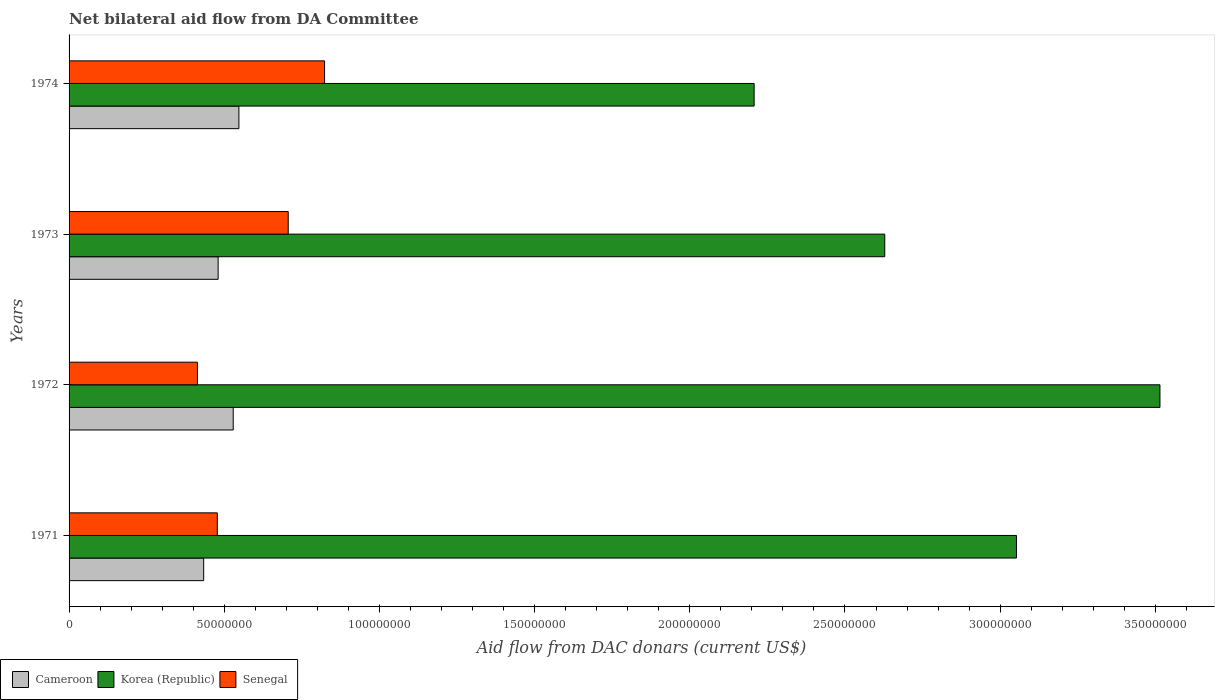How many groups of bars are there?
Offer a terse response. 4. How many bars are there on the 3rd tick from the top?
Your response must be concise. 3. What is the label of the 1st group of bars from the top?
Give a very brief answer. 1974. In how many cases, is the number of bars for a given year not equal to the number of legend labels?
Provide a succinct answer. 0. What is the aid flow in in Senegal in 1971?
Your answer should be very brief. 4.78e+07. Across all years, what is the maximum aid flow in in Senegal?
Offer a terse response. 8.23e+07. Across all years, what is the minimum aid flow in in Korea (Republic)?
Your answer should be very brief. 2.21e+08. What is the total aid flow in in Cameroon in the graph?
Provide a short and direct response. 1.99e+08. What is the difference between the aid flow in in Cameroon in 1972 and that in 1973?
Provide a short and direct response. 4.86e+06. What is the difference between the aid flow in in Korea (Republic) in 1973 and the aid flow in in Senegal in 1974?
Make the answer very short. 1.80e+08. What is the average aid flow in in Cameroon per year?
Ensure brevity in your answer.  4.98e+07. In the year 1971, what is the difference between the aid flow in in Cameroon and aid flow in in Korea (Republic)?
Provide a short and direct response. -2.62e+08. In how many years, is the aid flow in in Cameroon greater than 250000000 US$?
Your answer should be very brief. 0. What is the ratio of the aid flow in in Senegal in 1972 to that in 1974?
Give a very brief answer. 0.5. What is the difference between the highest and the second highest aid flow in in Senegal?
Offer a terse response. 1.17e+07. What is the difference between the highest and the lowest aid flow in in Korea (Republic)?
Make the answer very short. 1.31e+08. Is the sum of the aid flow in in Senegal in 1971 and 1973 greater than the maximum aid flow in in Korea (Republic) across all years?
Provide a succinct answer. No. What does the 3rd bar from the top in 1973 represents?
Your response must be concise. Cameroon. What does the 3rd bar from the bottom in 1971 represents?
Ensure brevity in your answer.  Senegal. Is it the case that in every year, the sum of the aid flow in in Senegal and aid flow in in Korea (Republic) is greater than the aid flow in in Cameroon?
Your response must be concise. Yes. How many bars are there?
Ensure brevity in your answer.  12. Are all the bars in the graph horizontal?
Your answer should be compact. Yes. What is the difference between two consecutive major ticks on the X-axis?
Give a very brief answer. 5.00e+07. Are the values on the major ticks of X-axis written in scientific E-notation?
Ensure brevity in your answer.  No. Does the graph contain any zero values?
Offer a very short reply. No. Does the graph contain grids?
Provide a short and direct response. No. Where does the legend appear in the graph?
Make the answer very short. Bottom left. What is the title of the graph?
Your answer should be very brief. Net bilateral aid flow from DA Committee. Does "Tajikistan" appear as one of the legend labels in the graph?
Offer a terse response. No. What is the label or title of the X-axis?
Your answer should be compact. Aid flow from DAC donars (current US$). What is the Aid flow from DAC donars (current US$) of Cameroon in 1971?
Offer a very short reply. 4.34e+07. What is the Aid flow from DAC donars (current US$) of Korea (Republic) in 1971?
Keep it short and to the point. 3.05e+08. What is the Aid flow from DAC donars (current US$) in Senegal in 1971?
Your answer should be compact. 4.78e+07. What is the Aid flow from DAC donars (current US$) of Cameroon in 1972?
Offer a terse response. 5.29e+07. What is the Aid flow from DAC donars (current US$) in Korea (Republic) in 1972?
Make the answer very short. 3.51e+08. What is the Aid flow from DAC donars (current US$) of Senegal in 1972?
Your response must be concise. 4.14e+07. What is the Aid flow from DAC donars (current US$) of Cameroon in 1973?
Offer a very short reply. 4.80e+07. What is the Aid flow from DAC donars (current US$) of Korea (Republic) in 1973?
Your answer should be very brief. 2.63e+08. What is the Aid flow from DAC donars (current US$) of Senegal in 1973?
Provide a succinct answer. 7.06e+07. What is the Aid flow from DAC donars (current US$) of Cameroon in 1974?
Keep it short and to the point. 5.47e+07. What is the Aid flow from DAC donars (current US$) of Korea (Republic) in 1974?
Offer a terse response. 2.21e+08. What is the Aid flow from DAC donars (current US$) of Senegal in 1974?
Give a very brief answer. 8.23e+07. Across all years, what is the maximum Aid flow from DAC donars (current US$) of Cameroon?
Provide a short and direct response. 5.47e+07. Across all years, what is the maximum Aid flow from DAC donars (current US$) in Korea (Republic)?
Your response must be concise. 3.51e+08. Across all years, what is the maximum Aid flow from DAC donars (current US$) of Senegal?
Your answer should be compact. 8.23e+07. Across all years, what is the minimum Aid flow from DAC donars (current US$) in Cameroon?
Your answer should be very brief. 4.34e+07. Across all years, what is the minimum Aid flow from DAC donars (current US$) of Korea (Republic)?
Make the answer very short. 2.21e+08. Across all years, what is the minimum Aid flow from DAC donars (current US$) in Senegal?
Keep it short and to the point. 4.14e+07. What is the total Aid flow from DAC donars (current US$) in Cameroon in the graph?
Your answer should be very brief. 1.99e+08. What is the total Aid flow from DAC donars (current US$) in Korea (Republic) in the graph?
Give a very brief answer. 1.14e+09. What is the total Aid flow from DAC donars (current US$) in Senegal in the graph?
Ensure brevity in your answer.  2.42e+08. What is the difference between the Aid flow from DAC donars (current US$) of Cameroon in 1971 and that in 1972?
Make the answer very short. -9.52e+06. What is the difference between the Aid flow from DAC donars (current US$) of Korea (Republic) in 1971 and that in 1972?
Keep it short and to the point. -4.62e+07. What is the difference between the Aid flow from DAC donars (current US$) of Senegal in 1971 and that in 1972?
Keep it short and to the point. 6.40e+06. What is the difference between the Aid flow from DAC donars (current US$) of Cameroon in 1971 and that in 1973?
Make the answer very short. -4.66e+06. What is the difference between the Aid flow from DAC donars (current US$) in Korea (Republic) in 1971 and that in 1973?
Provide a short and direct response. 4.24e+07. What is the difference between the Aid flow from DAC donars (current US$) of Senegal in 1971 and that in 1973?
Your response must be concise. -2.28e+07. What is the difference between the Aid flow from DAC donars (current US$) of Cameroon in 1971 and that in 1974?
Make the answer very short. -1.14e+07. What is the difference between the Aid flow from DAC donars (current US$) in Korea (Republic) in 1971 and that in 1974?
Your answer should be very brief. 8.45e+07. What is the difference between the Aid flow from DAC donars (current US$) of Senegal in 1971 and that in 1974?
Your response must be concise. -3.46e+07. What is the difference between the Aid flow from DAC donars (current US$) of Cameroon in 1972 and that in 1973?
Provide a short and direct response. 4.86e+06. What is the difference between the Aid flow from DAC donars (current US$) in Korea (Republic) in 1972 and that in 1973?
Provide a succinct answer. 8.87e+07. What is the difference between the Aid flow from DAC donars (current US$) in Senegal in 1972 and that in 1973?
Your response must be concise. -2.92e+07. What is the difference between the Aid flow from DAC donars (current US$) in Cameroon in 1972 and that in 1974?
Your answer should be very brief. -1.83e+06. What is the difference between the Aid flow from DAC donars (current US$) of Korea (Republic) in 1972 and that in 1974?
Your answer should be very brief. 1.31e+08. What is the difference between the Aid flow from DAC donars (current US$) in Senegal in 1972 and that in 1974?
Ensure brevity in your answer.  -4.10e+07. What is the difference between the Aid flow from DAC donars (current US$) in Cameroon in 1973 and that in 1974?
Give a very brief answer. -6.69e+06. What is the difference between the Aid flow from DAC donars (current US$) of Korea (Republic) in 1973 and that in 1974?
Offer a very short reply. 4.21e+07. What is the difference between the Aid flow from DAC donars (current US$) in Senegal in 1973 and that in 1974?
Make the answer very short. -1.17e+07. What is the difference between the Aid flow from DAC donars (current US$) of Cameroon in 1971 and the Aid flow from DAC donars (current US$) of Korea (Republic) in 1972?
Make the answer very short. -3.08e+08. What is the difference between the Aid flow from DAC donars (current US$) in Cameroon in 1971 and the Aid flow from DAC donars (current US$) in Senegal in 1972?
Make the answer very short. 2.01e+06. What is the difference between the Aid flow from DAC donars (current US$) in Korea (Republic) in 1971 and the Aid flow from DAC donars (current US$) in Senegal in 1972?
Your response must be concise. 2.64e+08. What is the difference between the Aid flow from DAC donars (current US$) of Cameroon in 1971 and the Aid flow from DAC donars (current US$) of Korea (Republic) in 1973?
Offer a terse response. -2.19e+08. What is the difference between the Aid flow from DAC donars (current US$) in Cameroon in 1971 and the Aid flow from DAC donars (current US$) in Senegal in 1973?
Give a very brief answer. -2.72e+07. What is the difference between the Aid flow from DAC donars (current US$) of Korea (Republic) in 1971 and the Aid flow from DAC donars (current US$) of Senegal in 1973?
Your answer should be compact. 2.35e+08. What is the difference between the Aid flow from DAC donars (current US$) in Cameroon in 1971 and the Aid flow from DAC donars (current US$) in Korea (Republic) in 1974?
Your answer should be very brief. -1.77e+08. What is the difference between the Aid flow from DAC donars (current US$) in Cameroon in 1971 and the Aid flow from DAC donars (current US$) in Senegal in 1974?
Your response must be concise. -3.90e+07. What is the difference between the Aid flow from DAC donars (current US$) of Korea (Republic) in 1971 and the Aid flow from DAC donars (current US$) of Senegal in 1974?
Ensure brevity in your answer.  2.23e+08. What is the difference between the Aid flow from DAC donars (current US$) in Cameroon in 1972 and the Aid flow from DAC donars (current US$) in Korea (Republic) in 1973?
Ensure brevity in your answer.  -2.10e+08. What is the difference between the Aid flow from DAC donars (current US$) of Cameroon in 1972 and the Aid flow from DAC donars (current US$) of Senegal in 1973?
Provide a short and direct response. -1.77e+07. What is the difference between the Aid flow from DAC donars (current US$) in Korea (Republic) in 1972 and the Aid flow from DAC donars (current US$) in Senegal in 1973?
Make the answer very short. 2.81e+08. What is the difference between the Aid flow from DAC donars (current US$) in Cameroon in 1972 and the Aid flow from DAC donars (current US$) in Korea (Republic) in 1974?
Ensure brevity in your answer.  -1.68e+08. What is the difference between the Aid flow from DAC donars (current US$) in Cameroon in 1972 and the Aid flow from DAC donars (current US$) in Senegal in 1974?
Your response must be concise. -2.94e+07. What is the difference between the Aid flow from DAC donars (current US$) of Korea (Republic) in 1972 and the Aid flow from DAC donars (current US$) of Senegal in 1974?
Offer a very short reply. 2.69e+08. What is the difference between the Aid flow from DAC donars (current US$) of Cameroon in 1973 and the Aid flow from DAC donars (current US$) of Korea (Republic) in 1974?
Offer a terse response. -1.73e+08. What is the difference between the Aid flow from DAC donars (current US$) of Cameroon in 1973 and the Aid flow from DAC donars (current US$) of Senegal in 1974?
Your answer should be very brief. -3.43e+07. What is the difference between the Aid flow from DAC donars (current US$) of Korea (Republic) in 1973 and the Aid flow from DAC donars (current US$) of Senegal in 1974?
Provide a short and direct response. 1.80e+08. What is the average Aid flow from DAC donars (current US$) in Cameroon per year?
Provide a succinct answer. 4.98e+07. What is the average Aid flow from DAC donars (current US$) of Korea (Republic) per year?
Give a very brief answer. 2.85e+08. What is the average Aid flow from DAC donars (current US$) of Senegal per year?
Your answer should be compact. 6.05e+07. In the year 1971, what is the difference between the Aid flow from DAC donars (current US$) of Cameroon and Aid flow from DAC donars (current US$) of Korea (Republic)?
Make the answer very short. -2.62e+08. In the year 1971, what is the difference between the Aid flow from DAC donars (current US$) in Cameroon and Aid flow from DAC donars (current US$) in Senegal?
Offer a very short reply. -4.39e+06. In the year 1971, what is the difference between the Aid flow from DAC donars (current US$) in Korea (Republic) and Aid flow from DAC donars (current US$) in Senegal?
Offer a very short reply. 2.57e+08. In the year 1972, what is the difference between the Aid flow from DAC donars (current US$) of Cameroon and Aid flow from DAC donars (current US$) of Korea (Republic)?
Your answer should be compact. -2.99e+08. In the year 1972, what is the difference between the Aid flow from DAC donars (current US$) in Cameroon and Aid flow from DAC donars (current US$) in Senegal?
Offer a very short reply. 1.15e+07. In the year 1972, what is the difference between the Aid flow from DAC donars (current US$) in Korea (Republic) and Aid flow from DAC donars (current US$) in Senegal?
Provide a short and direct response. 3.10e+08. In the year 1973, what is the difference between the Aid flow from DAC donars (current US$) in Cameroon and Aid flow from DAC donars (current US$) in Korea (Republic)?
Offer a very short reply. -2.15e+08. In the year 1973, what is the difference between the Aid flow from DAC donars (current US$) in Cameroon and Aid flow from DAC donars (current US$) in Senegal?
Keep it short and to the point. -2.26e+07. In the year 1973, what is the difference between the Aid flow from DAC donars (current US$) of Korea (Republic) and Aid flow from DAC donars (current US$) of Senegal?
Offer a very short reply. 1.92e+08. In the year 1974, what is the difference between the Aid flow from DAC donars (current US$) of Cameroon and Aid flow from DAC donars (current US$) of Korea (Republic)?
Provide a short and direct response. -1.66e+08. In the year 1974, what is the difference between the Aid flow from DAC donars (current US$) of Cameroon and Aid flow from DAC donars (current US$) of Senegal?
Ensure brevity in your answer.  -2.76e+07. In the year 1974, what is the difference between the Aid flow from DAC donars (current US$) in Korea (Republic) and Aid flow from DAC donars (current US$) in Senegal?
Give a very brief answer. 1.38e+08. What is the ratio of the Aid flow from DAC donars (current US$) in Cameroon in 1971 to that in 1972?
Offer a very short reply. 0.82. What is the ratio of the Aid flow from DAC donars (current US$) of Korea (Republic) in 1971 to that in 1972?
Ensure brevity in your answer.  0.87. What is the ratio of the Aid flow from DAC donars (current US$) of Senegal in 1971 to that in 1972?
Give a very brief answer. 1.15. What is the ratio of the Aid flow from DAC donars (current US$) in Cameroon in 1971 to that in 1973?
Keep it short and to the point. 0.9. What is the ratio of the Aid flow from DAC donars (current US$) in Korea (Republic) in 1971 to that in 1973?
Your response must be concise. 1.16. What is the ratio of the Aid flow from DAC donars (current US$) of Senegal in 1971 to that in 1973?
Your answer should be compact. 0.68. What is the ratio of the Aid flow from DAC donars (current US$) of Cameroon in 1971 to that in 1974?
Offer a very short reply. 0.79. What is the ratio of the Aid flow from DAC donars (current US$) of Korea (Republic) in 1971 to that in 1974?
Your answer should be very brief. 1.38. What is the ratio of the Aid flow from DAC donars (current US$) in Senegal in 1971 to that in 1974?
Keep it short and to the point. 0.58. What is the ratio of the Aid flow from DAC donars (current US$) in Cameroon in 1972 to that in 1973?
Provide a succinct answer. 1.1. What is the ratio of the Aid flow from DAC donars (current US$) of Korea (Republic) in 1972 to that in 1973?
Offer a very short reply. 1.34. What is the ratio of the Aid flow from DAC donars (current US$) in Senegal in 1972 to that in 1973?
Your response must be concise. 0.59. What is the ratio of the Aid flow from DAC donars (current US$) of Cameroon in 1972 to that in 1974?
Provide a succinct answer. 0.97. What is the ratio of the Aid flow from DAC donars (current US$) of Korea (Republic) in 1972 to that in 1974?
Provide a short and direct response. 1.59. What is the ratio of the Aid flow from DAC donars (current US$) of Senegal in 1972 to that in 1974?
Provide a succinct answer. 0.5. What is the ratio of the Aid flow from DAC donars (current US$) of Cameroon in 1973 to that in 1974?
Provide a short and direct response. 0.88. What is the ratio of the Aid flow from DAC donars (current US$) in Korea (Republic) in 1973 to that in 1974?
Ensure brevity in your answer.  1.19. What is the ratio of the Aid flow from DAC donars (current US$) in Senegal in 1973 to that in 1974?
Your answer should be compact. 0.86. What is the difference between the highest and the second highest Aid flow from DAC donars (current US$) of Cameroon?
Offer a terse response. 1.83e+06. What is the difference between the highest and the second highest Aid flow from DAC donars (current US$) of Korea (Republic)?
Keep it short and to the point. 4.62e+07. What is the difference between the highest and the second highest Aid flow from DAC donars (current US$) in Senegal?
Offer a terse response. 1.17e+07. What is the difference between the highest and the lowest Aid flow from DAC donars (current US$) of Cameroon?
Provide a short and direct response. 1.14e+07. What is the difference between the highest and the lowest Aid flow from DAC donars (current US$) in Korea (Republic)?
Keep it short and to the point. 1.31e+08. What is the difference between the highest and the lowest Aid flow from DAC donars (current US$) in Senegal?
Ensure brevity in your answer.  4.10e+07. 